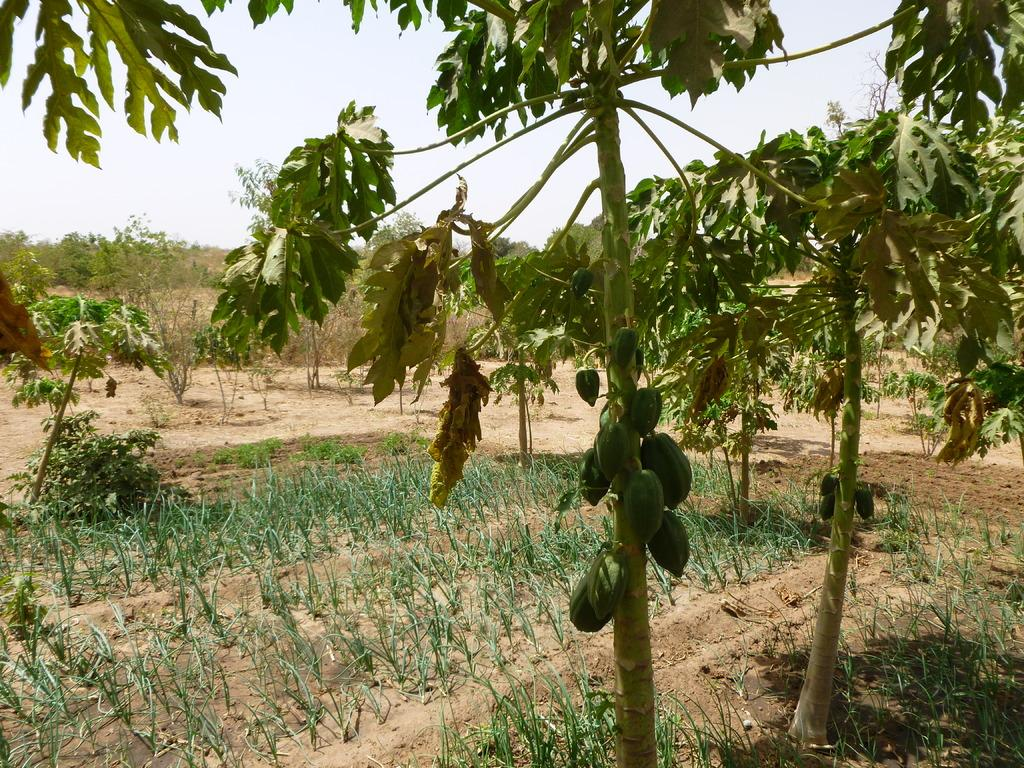What type of living organisms can be seen in the image? Plants and trees are visible in the image. What type of fruit can be seen in the image? There are papayas in the image. What can be seen in the background of the image? The sky is visible in the background of the image. What type of rings are being worn by the plants in the image? There are no rings present in the image, as it features plants and papayas. 